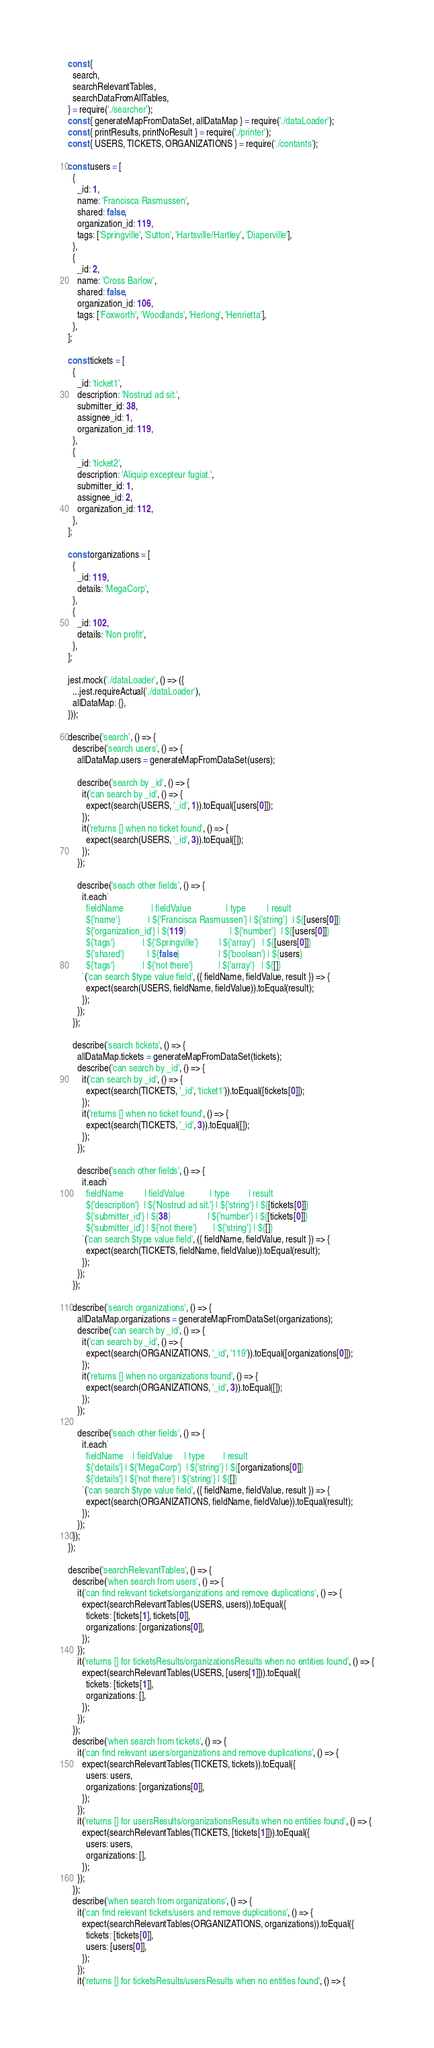Convert code to text. <code><loc_0><loc_0><loc_500><loc_500><_JavaScript_>const {
  search,
  searchRelevantTables,
  searchDataFromAllTables,
} = require('./searcher');
const { generateMapFromDataSet, allDataMap } = require('./dataLoader');
const { printResults, printNoResult } = require('./printer');
const { USERS, TICKETS, ORGANIZATIONS } = require('./contants');

const users = [
  {
    _id: 1,
    name: 'Francisca Rasmussen',
    shared: false,
    organization_id: 119,
    tags: ['Springville', 'Sutton', 'Hartsville/Hartley', 'Diaperville'],
  },
  {
    _id: 2,
    name: 'Cross Barlow',
    shared: false,
    organization_id: 106,
    tags: ['Foxworth', 'Woodlands', 'Herlong', 'Henrietta'],
  },
];

const tickets = [
  {
    _id: 'ticket1',
    description: 'Nostrud ad sit.',
    submitter_id: 38,
    assignee_id: 1,
    organization_id: 119,
  },
  {
    _id: 'ticket2',
    description: 'Aliquip excepteur fugiat.',
    submitter_id: 1,
    assignee_id: 2,
    organization_id: 112,
  },
];

const organizations = [
  {
    _id: 119,
    details: 'MegaCorp',
  },
  {
    _id: 102,
    details: 'Non profit',
  },
];

jest.mock('./dataLoader', () => ({
  ...jest.requireActual('./dataLoader'),
  allDataMap: {},
}));

describe('search', () => {
  describe('search users', () => {
    allDataMap.users = generateMapFromDataSet(users);

    describe('search by _id', () => {
      it('can search by _id', () => {
        expect(search(USERS, '_id', 1)).toEqual([users[0]]);
      });
      it('returns [] when no ticket found', () => {
        expect(search(USERS, '_id', 3)).toEqual([]);
      });
    });

    describe('seach other fields', () => {
      it.each`
        fieldName            | fieldValue               | type         | result
        ${'name'}            | ${'Francisca Rasmussen'} | ${'string'}  | ${[users[0]]}
        ${'organization_id'} | ${119}                   | ${'number'}  | ${[users[0]]}
        ${'tags'}            | ${'Springville'}         | ${'array'}   | ${[users[0]]}
        ${'shared'}          | ${false}                 | ${'boolean'} | ${users}
        ${'tags'}            | ${'not there'}           | ${'array'}   | ${[]}
      `('can search $type value field', ({ fieldName, fieldValue, result }) => {
        expect(search(USERS, fieldName, fieldValue)).toEqual(result);
      });
    });
  });

  describe('search tickets', () => {
    allDataMap.tickets = generateMapFromDataSet(tickets);
    describe('can search by _id', () => {
      it('can search by _id', () => {
        expect(search(TICKETS, '_id', 'ticket1')).toEqual([tickets[0]]);
      });
      it('returns [] when no ticket found', () => {
        expect(search(TICKETS, '_id', 3)).toEqual([]);
      });
    });

    describe('seach other fields', () => {
      it.each`
        fieldName         | fieldValue           | type        | result
        ${'description'}  | ${'Nostrud ad sit.'} | ${'string'} | ${[tickets[0]]}
        ${'submitter_id'} | ${38}                | ${'number'} | ${[tickets[0]]}
        ${'submitter_id'} | ${'not there'}       | ${'string'} | ${[]}
      `('can search $type value field', ({ fieldName, fieldValue, result }) => {
        expect(search(TICKETS, fieldName, fieldValue)).toEqual(result);
      });
    });
  });

  describe('search organizations', () => {
    allDataMap.organizations = generateMapFromDataSet(organizations);
    describe('can search by _id', () => {
      it('can search by _id', () => {
        expect(search(ORGANIZATIONS, '_id', '119')).toEqual([organizations[0]]);
      });
      it('returns [] when no organizations found', () => {
        expect(search(ORGANIZATIONS, '_id', 3)).toEqual([]);
      });
    });

    describe('seach other fields', () => {
      it.each`
        fieldName    | fieldValue     | type        | result
        ${'details'} | ${'MegaCorp'}  | ${'string'} | ${[organizations[0]]}
        ${'details'} | ${'not there'} | ${'string'} | ${[]}
      `('can search $type value field', ({ fieldName, fieldValue, result }) => {
        expect(search(ORGANIZATIONS, fieldName, fieldValue)).toEqual(result);
      });
    });
  });
});

describe('searchRelevantTables', () => {
  describe('when search from users', () => {
    it('can find relevant tickets/organizations and remove duplications', () => {
      expect(searchRelevantTables(USERS, users)).toEqual({
        tickets: [tickets[1], tickets[0]],
        organizations: [organizations[0]],
      });
    });
    it('returns [] for ticketsResults/organizationsResults when no entities found', () => {
      expect(searchRelevantTables(USERS, [users[1]])).toEqual({
        tickets: [tickets[1]],
        organizations: [],
      });
    });
  });
  describe('when search from tickets', () => {
    it('can find relevant users/organizations and remove duplications', () => {
      expect(searchRelevantTables(TICKETS, tickets)).toEqual({
        users: users,
        organizations: [organizations[0]],
      });
    });
    it('returns [] for usersResults/organizationsResults when no entities found', () => {
      expect(searchRelevantTables(TICKETS, [tickets[1]])).toEqual({
        users: users,
        organizations: [],
      });
    });
  });
  describe('when search from organizations', () => {
    it('can find relevant tickets/users and remove duplications', () => {
      expect(searchRelevantTables(ORGANIZATIONS, organizations)).toEqual({
        tickets: [tickets[0]],
        users: [users[0]],
      });
    });
    it('returns [] for ticketsResults/usersResults when no entities found', () => {</code> 